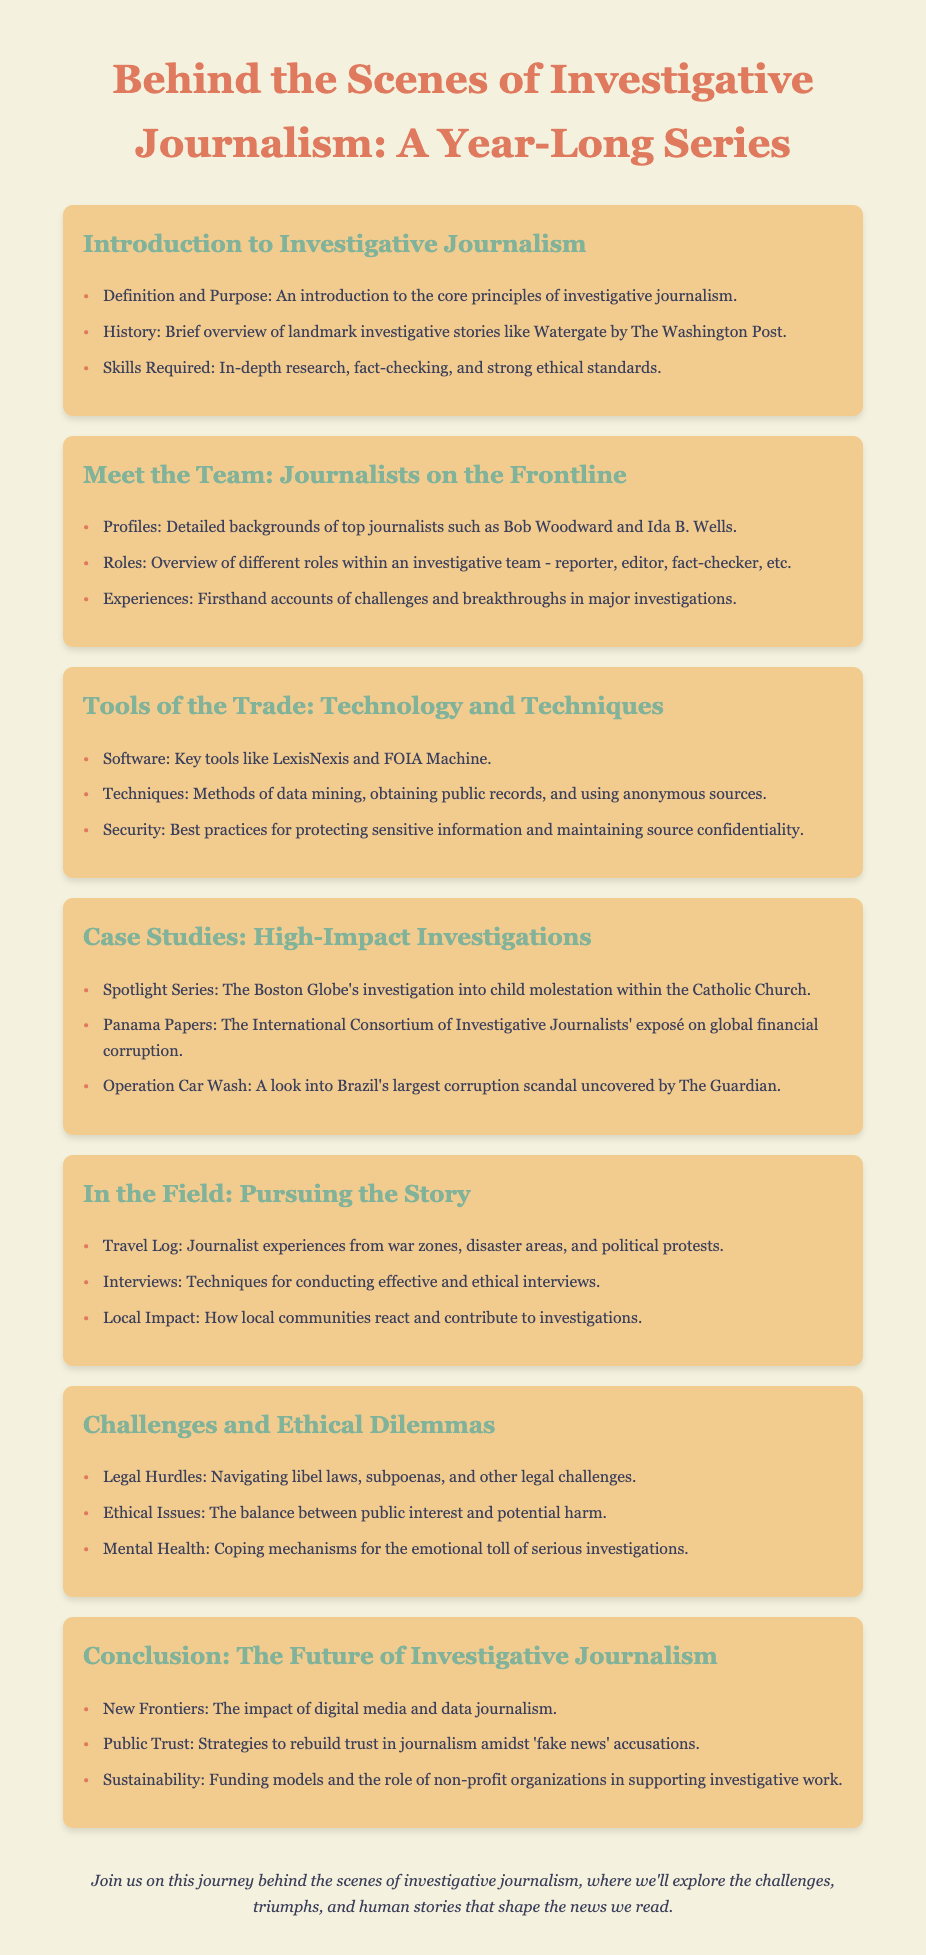What is the title of the series? The title of the series is presented prominently at the top of the document.
Answer: Behind the Scenes of Investigative Journalism: A Year-Long Series Who is one of the journalists profiled in the team section? The document lists notable journalists like Bob Woodward and Ida B. Wells.
Answer: Bob Woodward What is one of the tools mentioned in the tools of the trade section? The series describes various software used in investigative journalism, including specific names.
Answer: LexisNexis What landmark story is referenced in the introduction? The introduction discusses significant historical investigative stories, highlighting specific events.
Answer: Watergate Which case study is related to financial corruption? One of the case studies focuses on a global financial scandal and is an exposé by a consortium of journalists.
Answer: Panama Papers What section discusses ethical issues faced by journalists? This part of the document addresses moral dilemmas and challenges in the field of journalism.
Answer: Challenges and Ethical Dilemmas Which geographic environment is mentioned in the field experiences? The field experiences of journalists often involve various challenging locations during investigations.
Answer: War zones What time frame is covered by this investigative journalism series? The document outlines a specific duration over which the series takes place.
Answer: A year-long series What is the conclusion section about? This section summarizes the future considerations and evolving dynamics within investigative journalism.
Answer: The Future of Investigative Journalism 